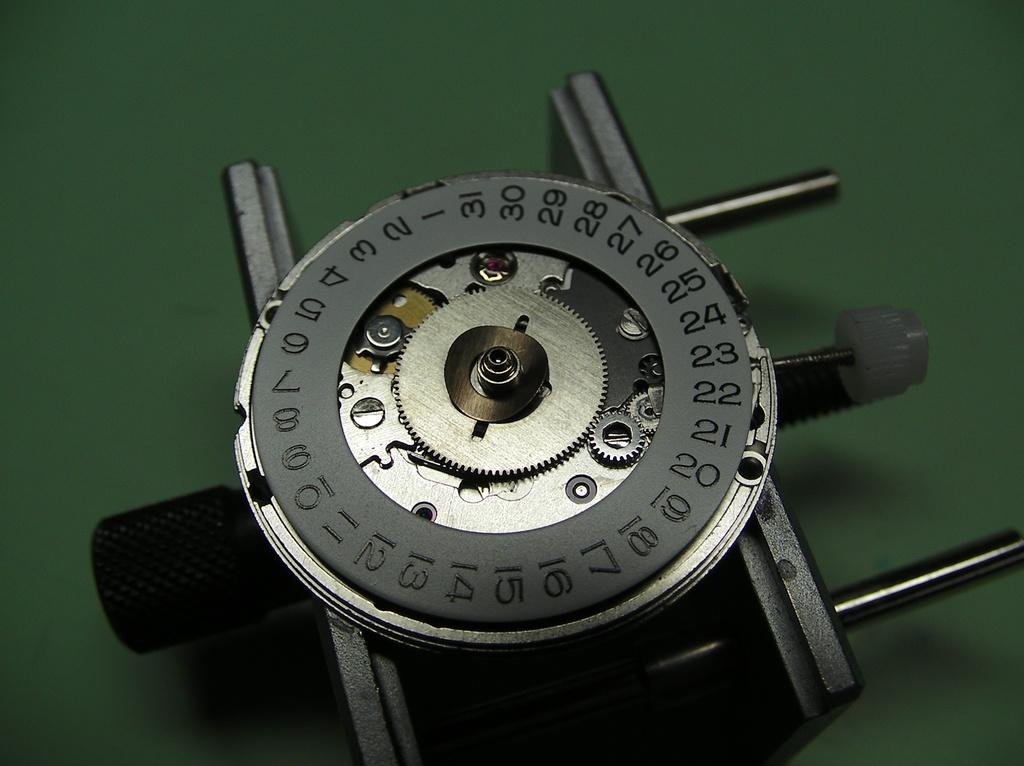<image>
Summarize the visual content of the image. A rustic clock with exposed cogs, with outer edge in black that has numbers 1 through 31 individually etched along entire perimeter. 